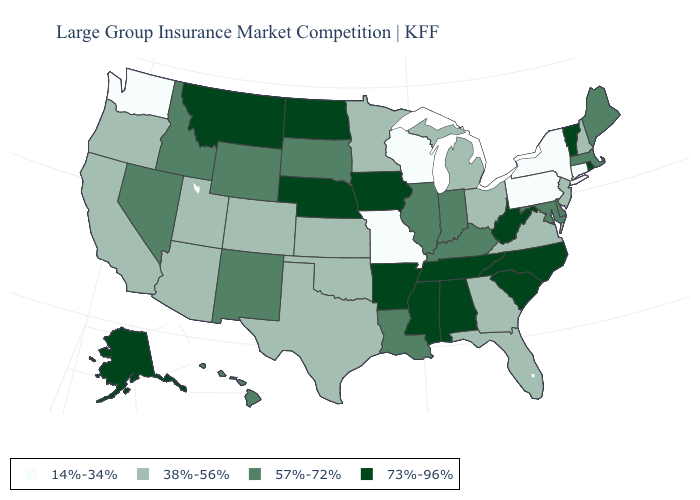How many symbols are there in the legend?
Quick response, please. 4. What is the highest value in the USA?
Give a very brief answer. 73%-96%. What is the value of Nebraska?
Concise answer only. 73%-96%. What is the lowest value in states that border Utah?
Concise answer only. 38%-56%. What is the value of Minnesota?
Answer briefly. 38%-56%. What is the value of Arkansas?
Quick response, please. 73%-96%. What is the highest value in the USA?
Keep it brief. 73%-96%. Does Indiana have a higher value than Louisiana?
Be succinct. No. What is the value of Rhode Island?
Answer briefly. 73%-96%. What is the highest value in the West ?
Concise answer only. 73%-96%. What is the lowest value in the Northeast?
Keep it brief. 14%-34%. Which states hav the highest value in the MidWest?
Concise answer only. Iowa, Nebraska, North Dakota. Name the states that have a value in the range 14%-34%?
Be succinct. Connecticut, Missouri, New York, Pennsylvania, Washington, Wisconsin. Name the states that have a value in the range 14%-34%?
Be succinct. Connecticut, Missouri, New York, Pennsylvania, Washington, Wisconsin. What is the highest value in the Northeast ?
Quick response, please. 73%-96%. 